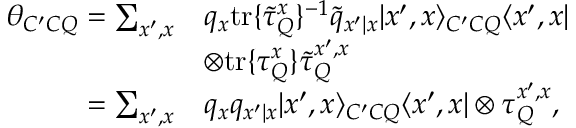Convert formula to latex. <formula><loc_0><loc_0><loc_500><loc_500>\begin{array} { r l } { \theta _ { C ^ { \prime } C Q } = \sum _ { x ^ { \prime } , x } } & { q _ { x } t r \{ \tilde { \tau } _ { Q } ^ { x } \} ^ { - 1 } \tilde { q } _ { x ^ { \prime } | x } | x ^ { \prime } , x \rangle _ { C ^ { \prime } C Q } \langle x ^ { \prime } , x | } \\ & { \otimes t r \{ \tau _ { Q } ^ { x } \} \tilde { \tau } _ { Q } ^ { x ^ { \prime } , x } } \\ { = \sum _ { x ^ { \prime } , x } } & { q _ { x } q _ { x ^ { \prime } | x } | x ^ { \prime } , x \rangle _ { C ^ { \prime } C Q } \langle x ^ { \prime } , x | \otimes \tau _ { Q } ^ { x ^ { \prime } , x } , } \end{array}</formula> 